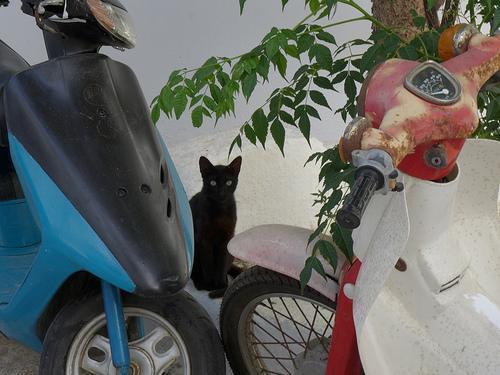How many cats are there?
Give a very brief answer. 1. How many bikes are there?
Give a very brief answer. 2. 